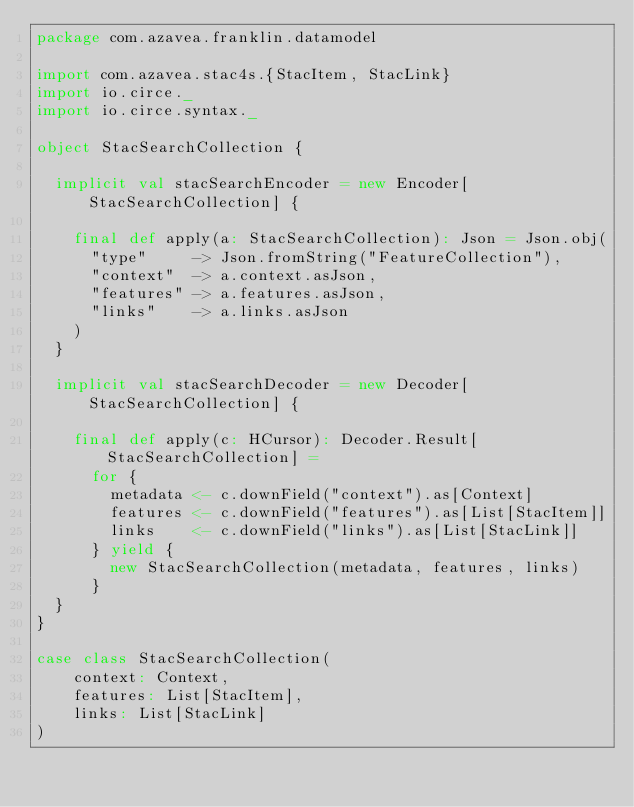Convert code to text. <code><loc_0><loc_0><loc_500><loc_500><_Scala_>package com.azavea.franklin.datamodel

import com.azavea.stac4s.{StacItem, StacLink}
import io.circe._
import io.circe.syntax._

object StacSearchCollection {

  implicit val stacSearchEncoder = new Encoder[StacSearchCollection] {

    final def apply(a: StacSearchCollection): Json = Json.obj(
      "type"     -> Json.fromString("FeatureCollection"),
      "context"  -> a.context.asJson,
      "features" -> a.features.asJson,
      "links"    -> a.links.asJson
    )
  }

  implicit val stacSearchDecoder = new Decoder[StacSearchCollection] {

    final def apply(c: HCursor): Decoder.Result[StacSearchCollection] =
      for {
        metadata <- c.downField("context").as[Context]
        features <- c.downField("features").as[List[StacItem]]
        links    <- c.downField("links").as[List[StacLink]]
      } yield {
        new StacSearchCollection(metadata, features, links)
      }
  }
}

case class StacSearchCollection(
    context: Context,
    features: List[StacItem],
    links: List[StacLink]
)
</code> 